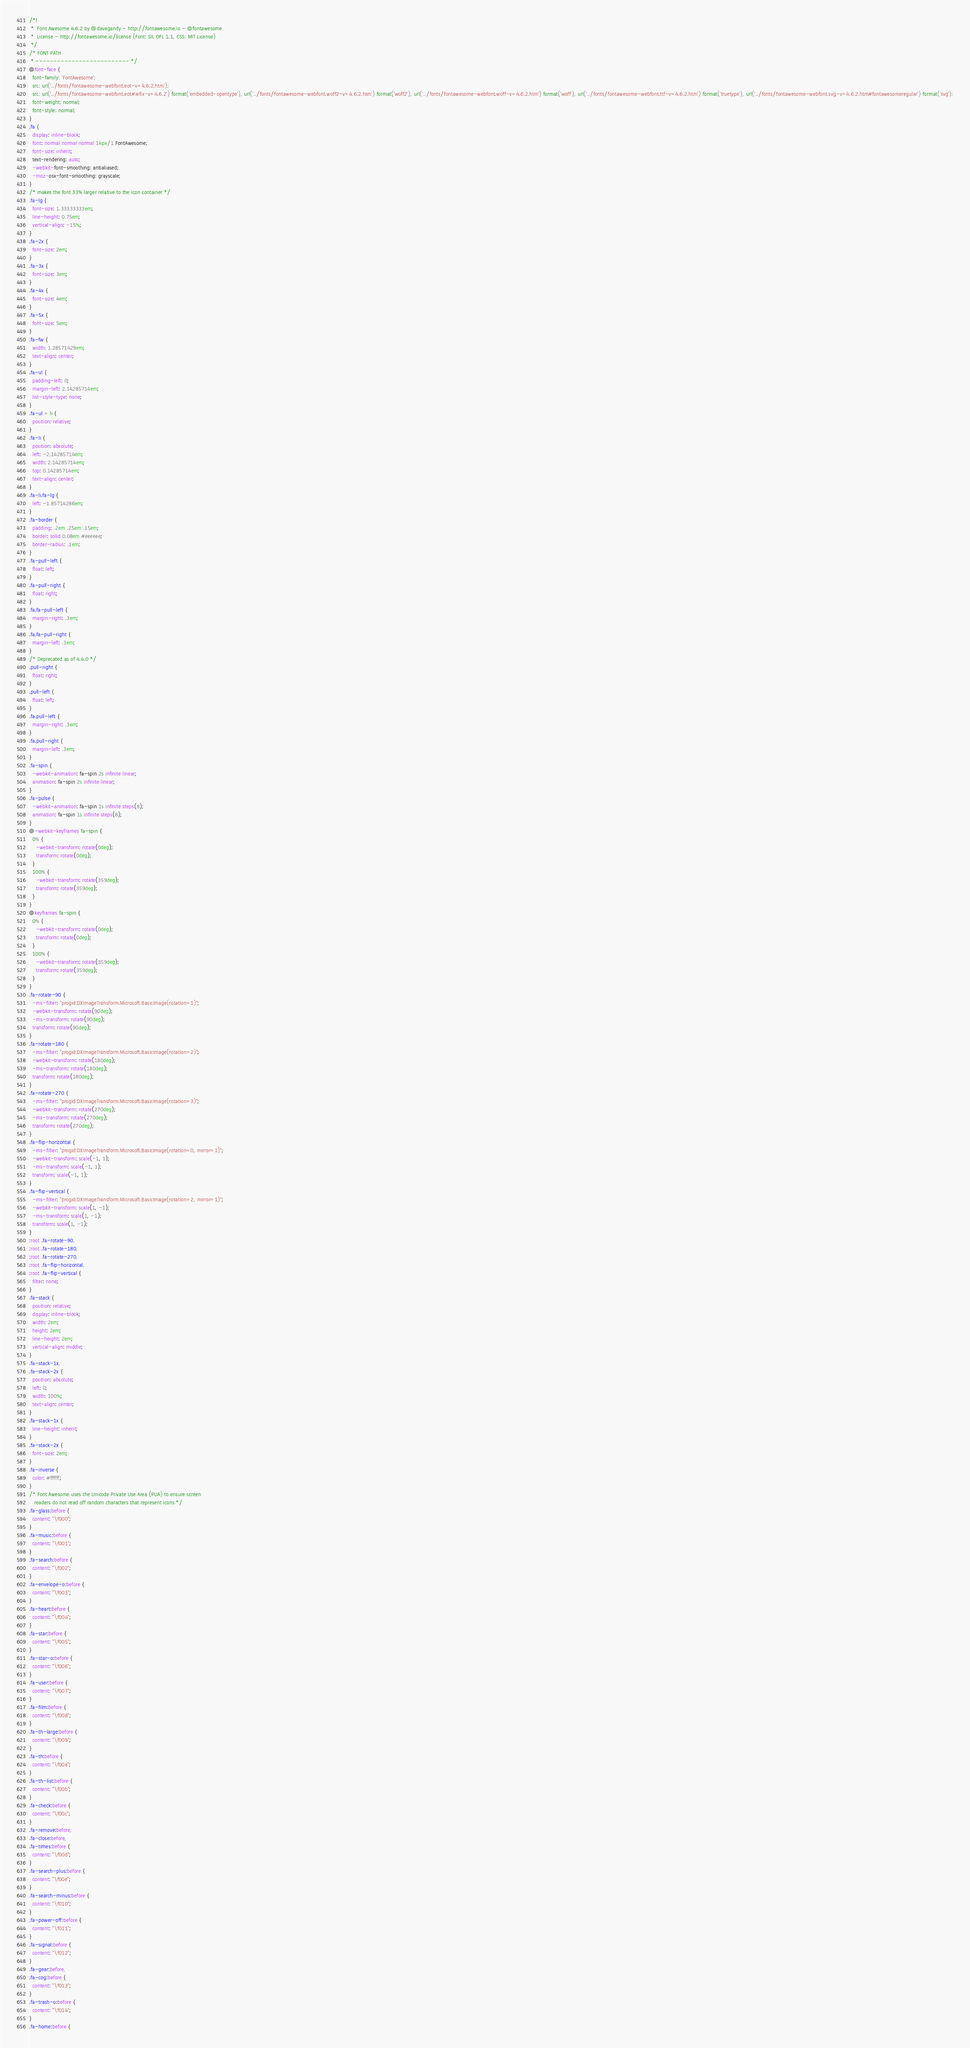Convert code to text. <code><loc_0><loc_0><loc_500><loc_500><_CSS_>/*!
 *  Font Awesome 4.6.2 by @davegandy - http://fontawesome.io - @fontawesome
 *  License - http://fontawesome.io/license (Font: SIL OFL 1.1, CSS: MIT License)
 */
/* FONT PATH
 * -------------------------- */
@font-face {
  font-family: 'FontAwesome';
  src: url('../fonts/fontawesome-webfont.eot-v=4.6.2.htm');
  src: url('../fonts/fontawesome-webfont.eot#iefix-v=4.6.2') format('embedded-opentype'), url('../fonts/fontawesome-webfont.woff2-v=4.6.2.htm') format('woff2'), url('../fonts/fontawesome-webfont.woff-v=4.6.2.htm') format('woff'), url('../fonts/fontawesome-webfont.ttf-v=4.6.2.htm') format('truetype'), url('../fonts/fontawesome-webfont.svg-v=4.6.2.htm#fontawesomeregular') format('svg');
  font-weight: normal;
  font-style: normal;
}
.fa {
  display: inline-block;
  font: normal normal normal 14px/1 FontAwesome;
  font-size: inherit;
  text-rendering: auto;
  -webkit-font-smoothing: antialiased;
  -moz-osx-font-smoothing: grayscale;
}
/* makes the font 33% larger relative to the icon container */
.fa-lg {
  font-size: 1.33333333em;
  line-height: 0.75em;
  vertical-align: -15%;
}
.fa-2x {
  font-size: 2em;
}
.fa-3x {
  font-size: 3em;
}
.fa-4x {
  font-size: 4em;
}
.fa-5x {
  font-size: 5em;
}
.fa-fw {
  width: 1.28571429em;
  text-align: center;
}
.fa-ul {
  padding-left: 0;
  margin-left: 2.14285714em;
  list-style-type: none;
}
.fa-ul > li {
  position: relative;
}
.fa-li {
  position: absolute;
  left: -2.14285714em;
  width: 2.14285714em;
  top: 0.14285714em;
  text-align: center;
}
.fa-li.fa-lg {
  left: -1.85714286em;
}
.fa-border {
  padding: .2em .25em .15em;
  border: solid 0.08em #eeeeee;
  border-radius: .1em;
}
.fa-pull-left {
  float: left;
}
.fa-pull-right {
  float: right;
}
.fa.fa-pull-left {
  margin-right: .3em;
}
.fa.fa-pull-right {
  margin-left: .3em;
}
/* Deprecated as of 4.4.0 */
.pull-right {
  float: right;
}
.pull-left {
  float: left;
}
.fa.pull-left {
  margin-right: .3em;
}
.fa.pull-right {
  margin-left: .3em;
}
.fa-spin {
  -webkit-animation: fa-spin 2s infinite linear;
  animation: fa-spin 2s infinite linear;
}
.fa-pulse {
  -webkit-animation: fa-spin 1s infinite steps(8);
  animation: fa-spin 1s infinite steps(8);
}
@-webkit-keyframes fa-spin {
  0% {
    -webkit-transform: rotate(0deg);
    transform: rotate(0deg);
  }
  100% {
    -webkit-transform: rotate(359deg);
    transform: rotate(359deg);
  }
}
@keyframes fa-spin {
  0% {
    -webkit-transform: rotate(0deg);
    transform: rotate(0deg);
  }
  100% {
    -webkit-transform: rotate(359deg);
    transform: rotate(359deg);
  }
}
.fa-rotate-90 {
  -ms-filter: "progid:DXImageTransform.Microsoft.BasicImage(rotation=1)";
  -webkit-transform: rotate(90deg);
  -ms-transform: rotate(90deg);
  transform: rotate(90deg);
}
.fa-rotate-180 {
  -ms-filter: "progid:DXImageTransform.Microsoft.BasicImage(rotation=2)";
  -webkit-transform: rotate(180deg);
  -ms-transform: rotate(180deg);
  transform: rotate(180deg);
}
.fa-rotate-270 {
  -ms-filter: "progid:DXImageTransform.Microsoft.BasicImage(rotation=3)";
  -webkit-transform: rotate(270deg);
  -ms-transform: rotate(270deg);
  transform: rotate(270deg);
}
.fa-flip-horizontal {
  -ms-filter: "progid:DXImageTransform.Microsoft.BasicImage(rotation=0, mirror=1)";
  -webkit-transform: scale(-1, 1);
  -ms-transform: scale(-1, 1);
  transform: scale(-1, 1);
}
.fa-flip-vertical {
  -ms-filter: "progid:DXImageTransform.Microsoft.BasicImage(rotation=2, mirror=1)";
  -webkit-transform: scale(1, -1);
  -ms-transform: scale(1, -1);
  transform: scale(1, -1);
}
:root .fa-rotate-90,
:root .fa-rotate-180,
:root .fa-rotate-270,
:root .fa-flip-horizontal,
:root .fa-flip-vertical {
  filter: none;
}
.fa-stack {
  position: relative;
  display: inline-block;
  width: 2em;
  height: 2em;
  line-height: 2em;
  vertical-align: middle;
}
.fa-stack-1x,
.fa-stack-2x {
  position: absolute;
  left: 0;
  width: 100%;
  text-align: center;
}
.fa-stack-1x {
  line-height: inherit;
}
.fa-stack-2x {
  font-size: 2em;
}
.fa-inverse {
  color: #ffffff;
}
/* Font Awesome uses the Unicode Private Use Area (PUA) to ensure screen
   readers do not read off random characters that represent icons */
.fa-glass:before {
  content: "\f000";
}
.fa-music:before {
  content: "\f001";
}
.fa-search:before {
  content: "\f002";
}
.fa-envelope-o:before {
  content: "\f003";
}
.fa-heart:before {
  content: "\f004";
}
.fa-star:before {
  content: "\f005";
}
.fa-star-o:before {
  content: "\f006";
}
.fa-user:before {
  content: "\f007";
}
.fa-film:before {
  content: "\f008";
}
.fa-th-large:before {
  content: "\f009";
}
.fa-th:before {
  content: "\f00a";
}
.fa-th-list:before {
  content: "\f00b";
}
.fa-check:before {
  content: "\f00c";
}
.fa-remove:before,
.fa-close:before,
.fa-times:before {
  content: "\f00d";
}
.fa-search-plus:before {
  content: "\f00e";
}
.fa-search-minus:before {
  content: "\f010";
}
.fa-power-off:before {
  content: "\f011";
}
.fa-signal:before {
  content: "\f012";
}
.fa-gear:before,
.fa-cog:before {
  content: "\f013";
}
.fa-trash-o:before {
  content: "\f014";
}
.fa-home:before {</code> 